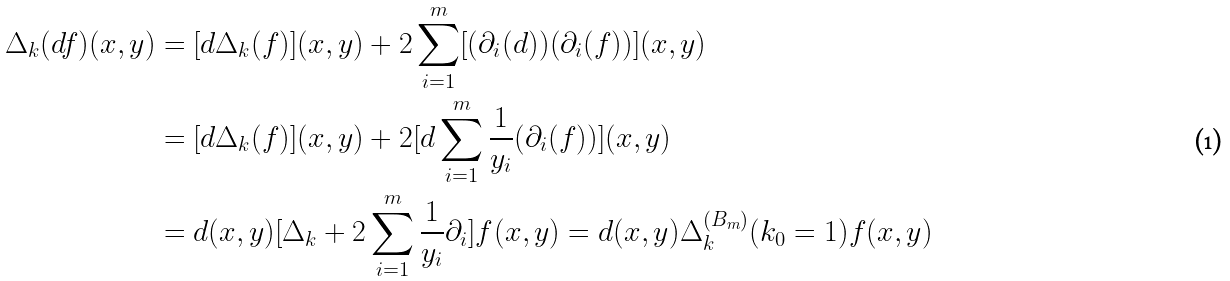<formula> <loc_0><loc_0><loc_500><loc_500>\Delta _ { k } ( d f ) ( x , y ) & = [ d \Delta _ { k } ( f ) ] ( x , y ) + 2 \sum _ { i = 1 } ^ { m } [ ( \partial _ { i } ( d ) ) ( \partial _ { i } ( f ) ) ] ( x , y ) \\ & = [ d \Delta _ { k } ( f ) ] ( x , y ) + 2 [ d \sum _ { i = 1 } ^ { m } \frac { 1 } { y _ { i } } ( \partial _ { i } ( f ) ) ] ( x , y ) \\ & = d ( x , y ) [ \Delta _ { k } + 2 \sum _ { i = 1 } ^ { m } \frac { 1 } { y _ { i } } \partial _ { i } ] f ( x , y ) = d ( x , y ) \Delta _ { k } ^ { ( B _ { m } ) } ( k _ { 0 } = 1 ) f ( x , y )</formula> 